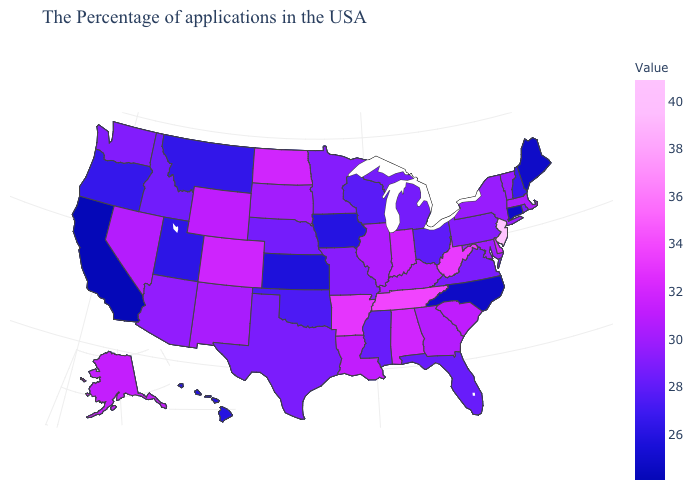Among the states that border Louisiana , which have the highest value?
Be succinct. Arkansas. Which states hav the highest value in the Northeast?
Concise answer only. New Jersey. Does the map have missing data?
Concise answer only. No. Does Wisconsin have the highest value in the MidWest?
Quick response, please. No. Which states hav the highest value in the MidWest?
Keep it brief. North Dakota. Does New Jersey have the highest value in the USA?
Write a very short answer. Yes. 